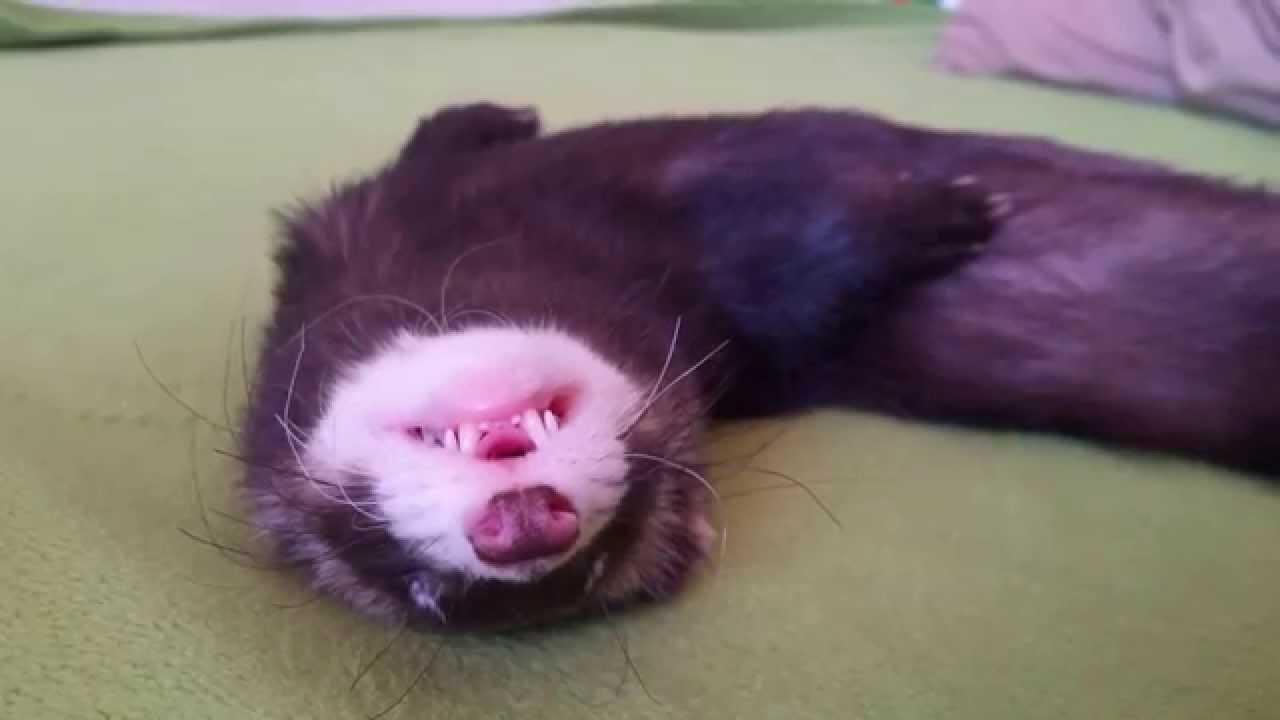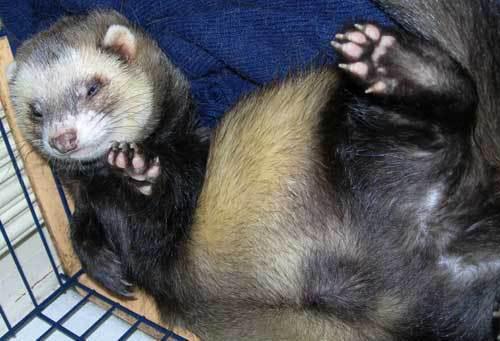The first image is the image on the left, the second image is the image on the right. Analyze the images presented: Is the assertion "Not even one of the animals appears to be awake and alert; they all seem tired, or are sleeping." valid? Answer yes or no. Yes. 